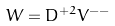<formula> <loc_0><loc_0><loc_500><loc_500>W = D ^ { + 2 } V ^ { - - }</formula> 